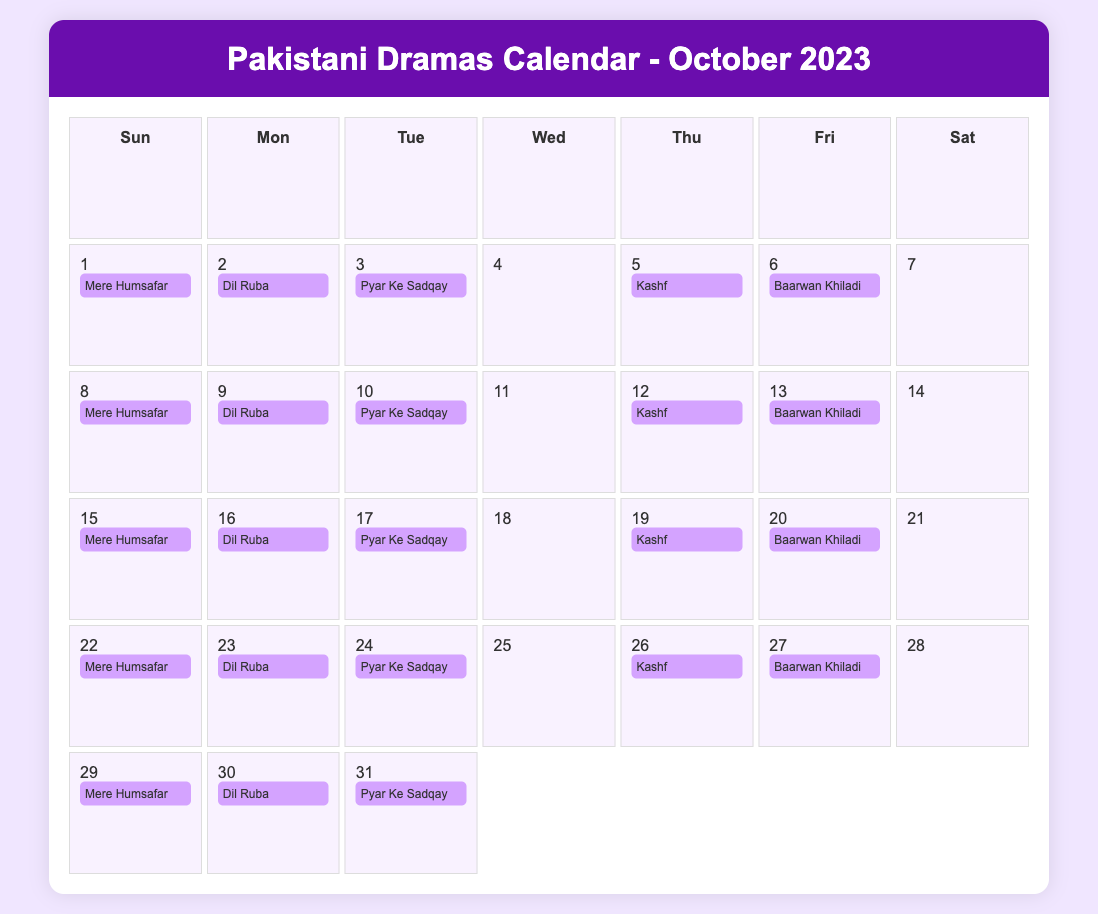What is the title of the drama airing on October 1? The title of the drama aired on October 1 is "Mere Humsafar."
Answer: Mere Humsafar How many dramas feature on October 2? There is one drama featured on October 2, which is "Dil Ruba."
Answer: 1 What is the synopsis of "Kashf"? The synopsis of "Kashf" describes a young woman with the gift of foresight who navigates personal struggles while trying to protect her family.
Answer: A young woman with a unique gift of foresight On which day does "Baarwan Khiladi" air for the first time in October? "Baarwan Khiladi" airs for the first time on October 6.
Answer: October 6 Which drama has the recurring air date of October 15? The drama that airs on October 15 is "Mere Humsafar."
Answer: Mere Humsafar How many times does "Dil Ruba" air in October? "Dil Ruba" airs a total of five times in October.
Answer: Five times What day of the week is October 20? October 20 is a Friday.
Answer: Friday What type of drama is "Baarwan Khiladi"? "Baarwan Khiladi" is categorized as a sports drama.
Answer: Sports drama 